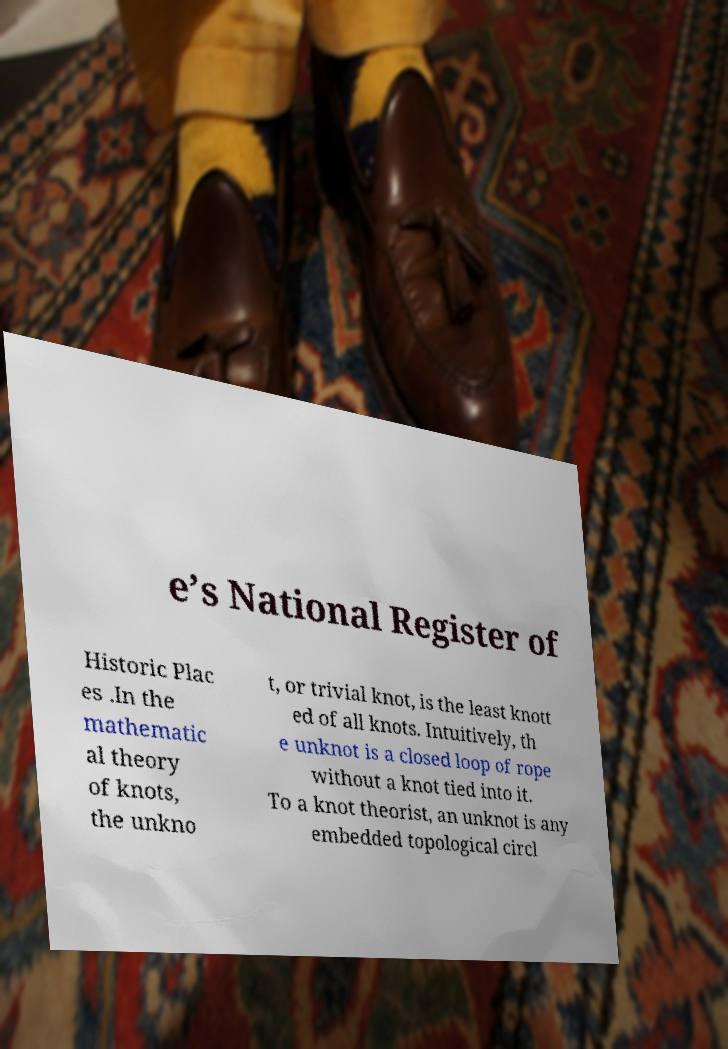There's text embedded in this image that I need extracted. Can you transcribe it verbatim? e’s National Register of Historic Plac es .In the mathematic al theory of knots, the unkno t, or trivial knot, is the least knott ed of all knots. Intuitively, th e unknot is a closed loop of rope without a knot tied into it. To a knot theorist, an unknot is any embedded topological circl 